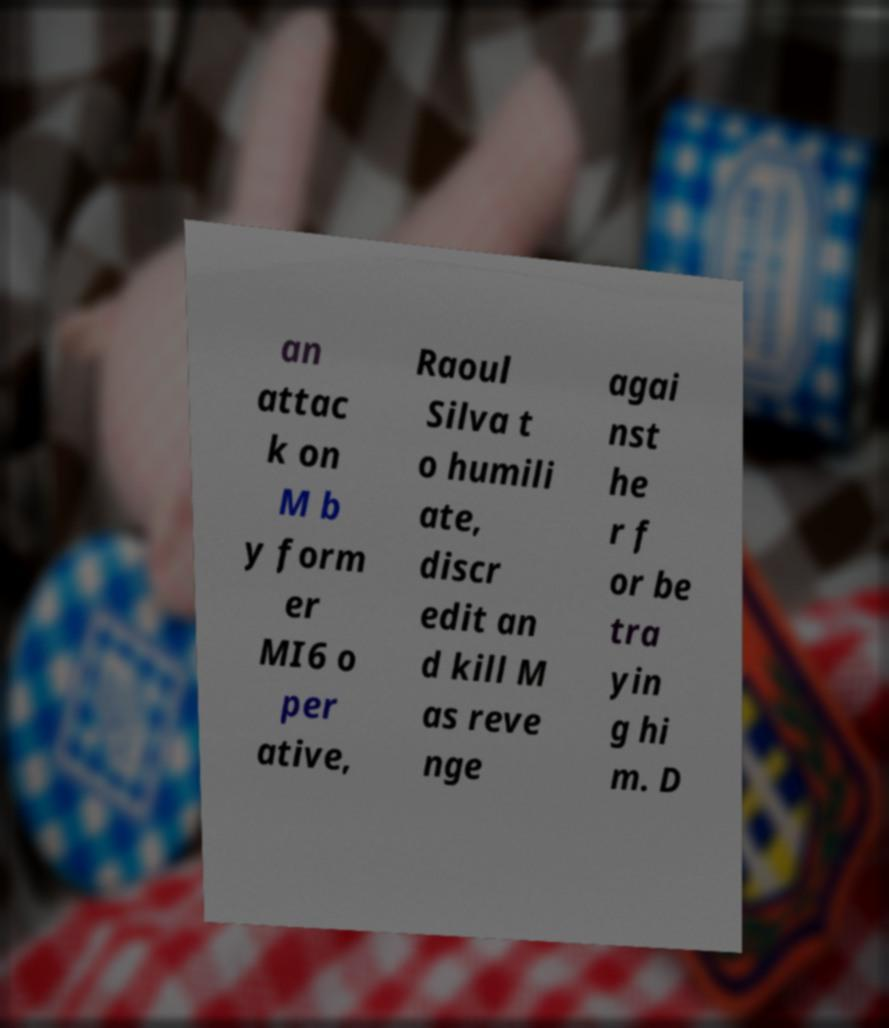For documentation purposes, I need the text within this image transcribed. Could you provide that? an attac k on M b y form er MI6 o per ative, Raoul Silva t o humili ate, discr edit an d kill M as reve nge agai nst he r f or be tra yin g hi m. D 